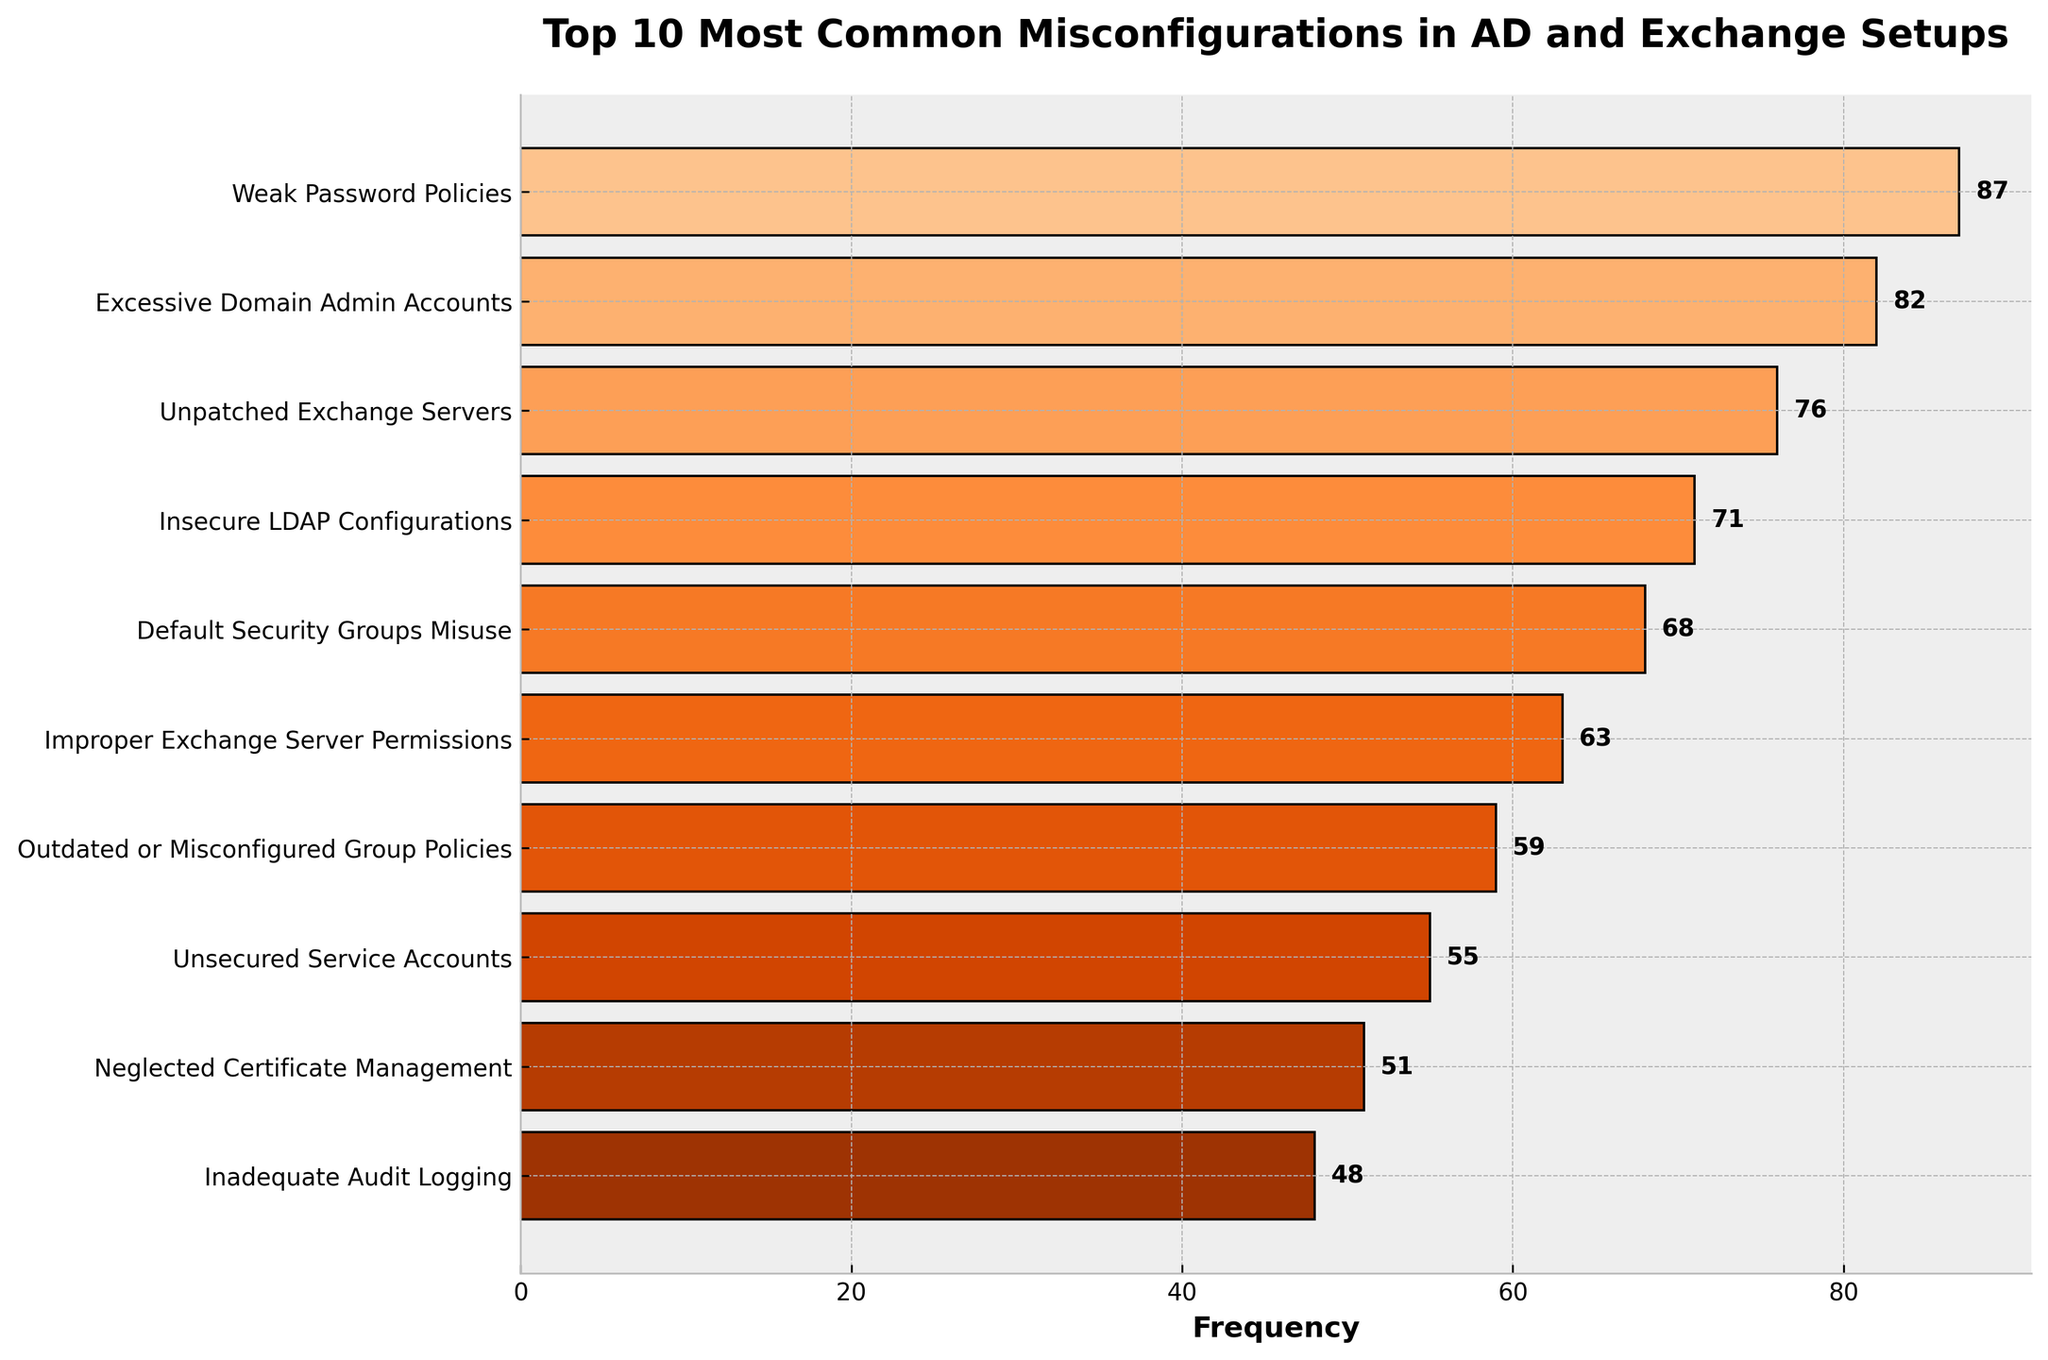Which misconfiguration occurs most frequently? The bar chart shows the frequency of each misconfiguration. The tallest bar represents the most frequent misconfiguration: "Weak Password Policies" with a frequency of 87.
Answer: Weak Password Policies What is the combined frequency of "Improper Exchange Server Permissions" and "Neglected Certificate Management"? Add the frequencies of "Improper Exchange Server Permissions" (63) and "Neglected Certificate Management" (51). 63 + 51 = 114.
Answer: 114 Are there more occurrences of "Insecure LDAP Configurations" or "Default Security Groups Misuse"? Compare the frequency of "Insecure LDAP Configurations" (71) with "Default Security Groups Misuse" (68). 71 is greater than 68.
Answer: Insecure LDAP Configurations What's the difference in occurrence between "Unpatched Exchange Servers" and "Insecure LDAP Configurations"? Take the frequencies of "Unpatched Exchange Servers" (76) and "Insecure LDAP Configurations" (71). Subtract 71 from 76. 76 - 71 = 5.
Answer: 5 Which misconfiguration has the lowest frequency? The shortest bar in the plot represents "Inadequate Audit Logging", with a frequency of 48.
Answer: Inadequate Audit Logging What is the average frequency of all the listed misconfigurations? Add the frequencies of all misconfigurations and divide by the number of misconfigurations. (87 + 82 + 76 + 71 + 68 + 63 + 59 + 55 + 51 + 48) / 10 = 66
Answer: 66 Are there any misconfigurations whose frequency is exactly 59? Look at the bars and their labels. "Outdated or Misconfigured Group Policies" has a frequency of 59.
Answer: Yes How much higher is the occurrence of "Weak Password Policies" compared to "Inadequate Audit Logging"? Subtract the frequency of "Inadequate Audit Logging" (48) from "Weak Password Policies" (87). 87 - 48 = 39.
Answer: 39 What is the second most common misconfiguration? Identify the second tallest bar which represents "Excessive Domain Admin Accounts" with a frequency of 82.
Answer: Excessive Domain Admin Accounts 